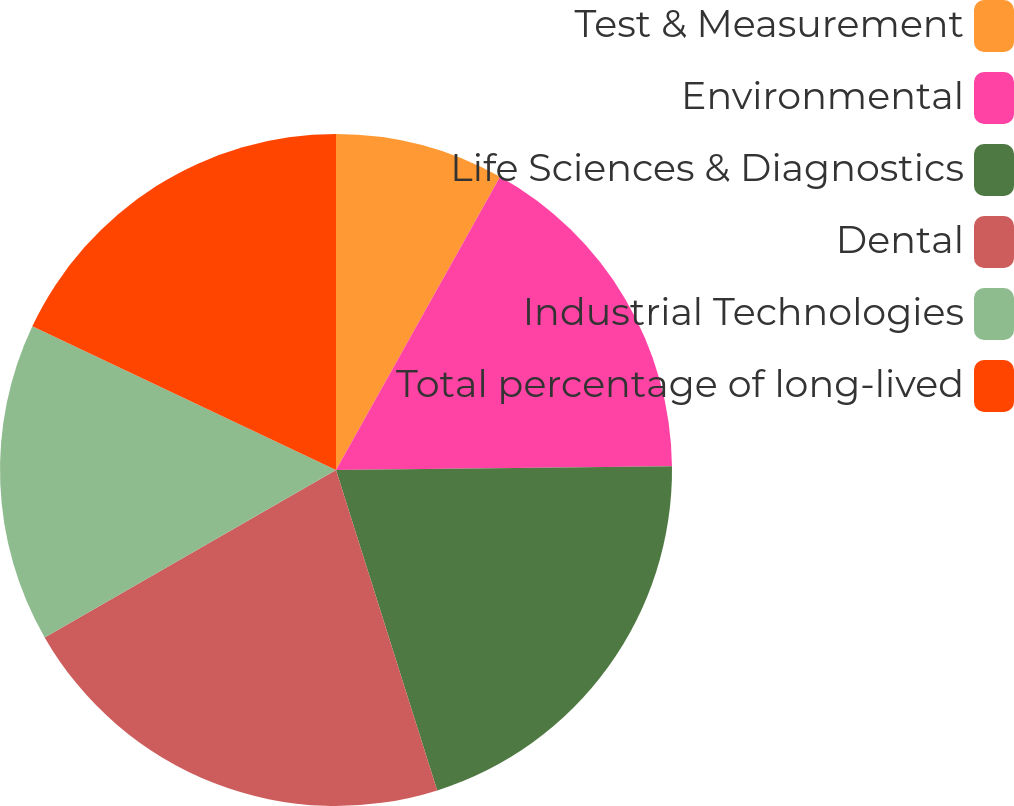Convert chart to OTSL. <chart><loc_0><loc_0><loc_500><loc_500><pie_chart><fcel>Test & Measurement<fcel>Environmental<fcel>Life Sciences & Diagnostics<fcel>Dental<fcel>Industrial Technologies<fcel>Total percentage of long-lived<nl><fcel>8.12%<fcel>16.7%<fcel>20.31%<fcel>21.57%<fcel>15.34%<fcel>17.96%<nl></chart> 